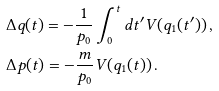<formula> <loc_0><loc_0><loc_500><loc_500>& \Delta q ( t ) = - \frac { 1 } { p _ { 0 } } \int _ { 0 } ^ { t } d t ^ { \prime } V ( q _ { 1 } ( t ^ { \prime } ) ) \, , \\ & \Delta p ( t ) = - \frac { m } { p _ { 0 } } V ( q _ { 1 } ( t ) ) \, .</formula> 